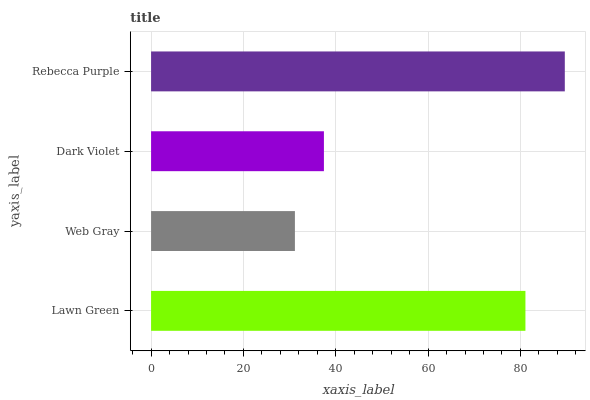Is Web Gray the minimum?
Answer yes or no. Yes. Is Rebecca Purple the maximum?
Answer yes or no. Yes. Is Dark Violet the minimum?
Answer yes or no. No. Is Dark Violet the maximum?
Answer yes or no. No. Is Dark Violet greater than Web Gray?
Answer yes or no. Yes. Is Web Gray less than Dark Violet?
Answer yes or no. Yes. Is Web Gray greater than Dark Violet?
Answer yes or no. No. Is Dark Violet less than Web Gray?
Answer yes or no. No. Is Lawn Green the high median?
Answer yes or no. Yes. Is Dark Violet the low median?
Answer yes or no. Yes. Is Rebecca Purple the high median?
Answer yes or no. No. Is Lawn Green the low median?
Answer yes or no. No. 